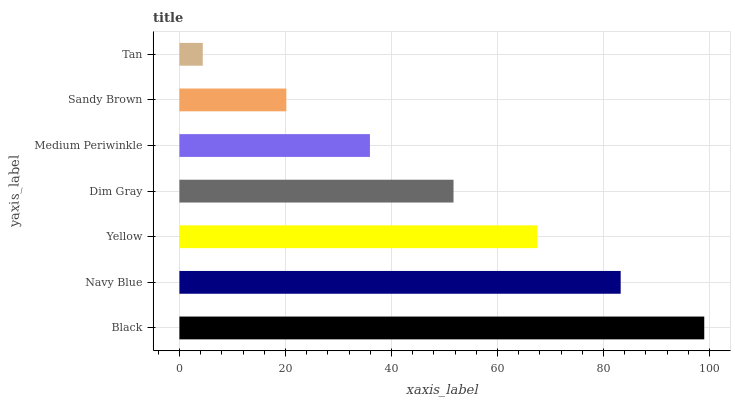Is Tan the minimum?
Answer yes or no. Yes. Is Black the maximum?
Answer yes or no. Yes. Is Navy Blue the minimum?
Answer yes or no. No. Is Navy Blue the maximum?
Answer yes or no. No. Is Black greater than Navy Blue?
Answer yes or no. Yes. Is Navy Blue less than Black?
Answer yes or no. Yes. Is Navy Blue greater than Black?
Answer yes or no. No. Is Black less than Navy Blue?
Answer yes or no. No. Is Dim Gray the high median?
Answer yes or no. Yes. Is Dim Gray the low median?
Answer yes or no. Yes. Is Yellow the high median?
Answer yes or no. No. Is Sandy Brown the low median?
Answer yes or no. No. 